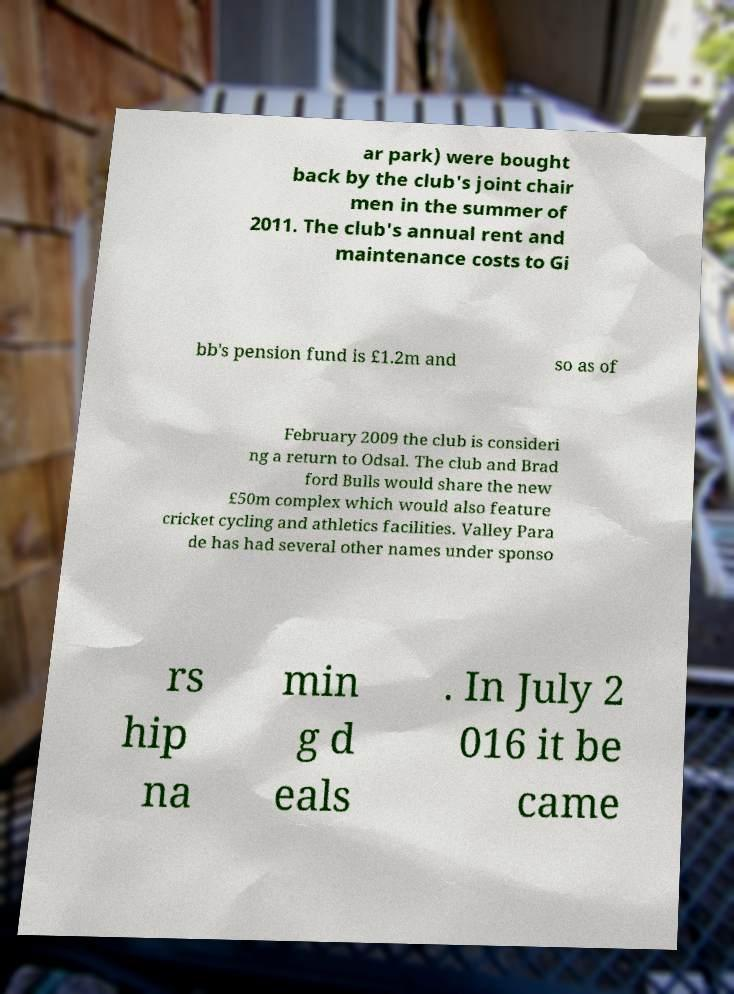Can you accurately transcribe the text from the provided image for me? ar park) were bought back by the club's joint chair men in the summer of 2011. The club's annual rent and maintenance costs to Gi bb's pension fund is £1.2m and so as of February 2009 the club is consideri ng a return to Odsal. The club and Brad ford Bulls would share the new £50m complex which would also feature cricket cycling and athletics facilities. Valley Para de has had several other names under sponso rs hip na min g d eals . In July 2 016 it be came 